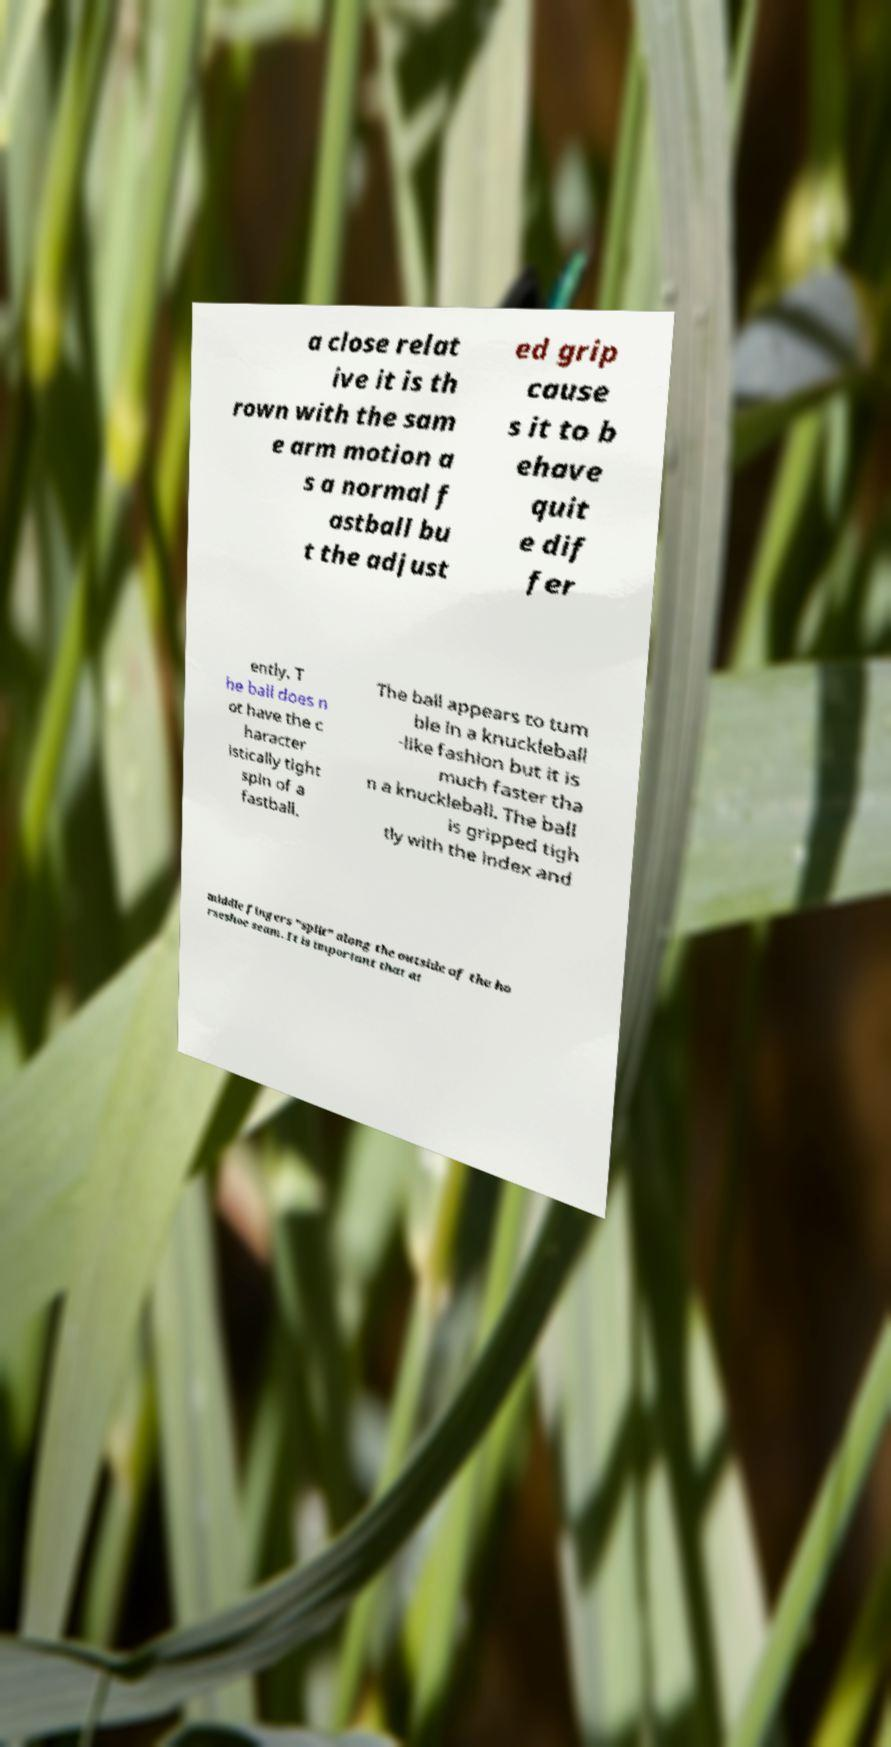For documentation purposes, I need the text within this image transcribed. Could you provide that? a close relat ive it is th rown with the sam e arm motion a s a normal f astball bu t the adjust ed grip cause s it to b ehave quit e dif fer ently. T he ball does n ot have the c haracter istically tight spin of a fastball. The ball appears to tum ble in a knuckleball -like fashion but it is much faster tha n a knuckleball. The ball is gripped tigh tly with the index and middle fingers "split" along the outside of the ho rseshoe seam. It is important that at 